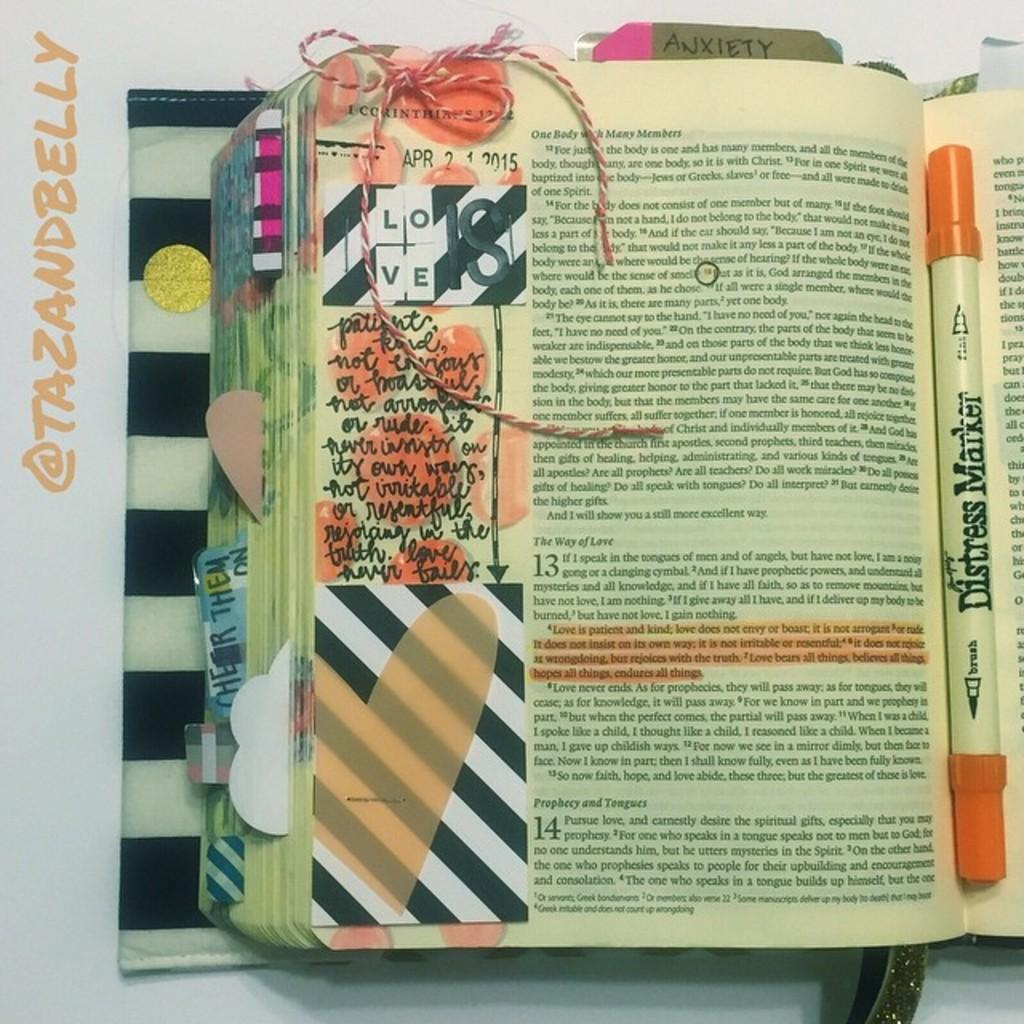Provide a one-sentence caption for the provided image. A page of a book is marked up with a "distress marker.". 